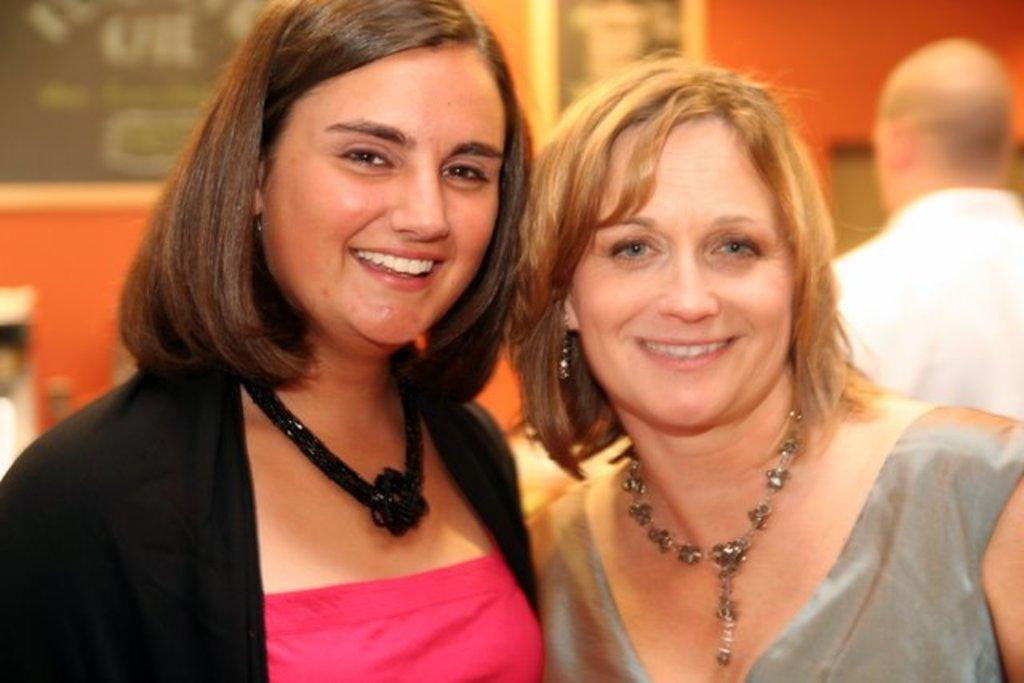How many women are in the image? There are two women in the image. What expression do the women have? The women are smiling. Can you describe the background of the image? There is a person, frames on the wall, and some objects in the background of the image. What type of knife is being used to touch the sky in the image? There is no knife or sky present in the image. 